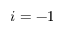Convert formula to latex. <formula><loc_0><loc_0><loc_500><loc_500>i = - 1</formula> 